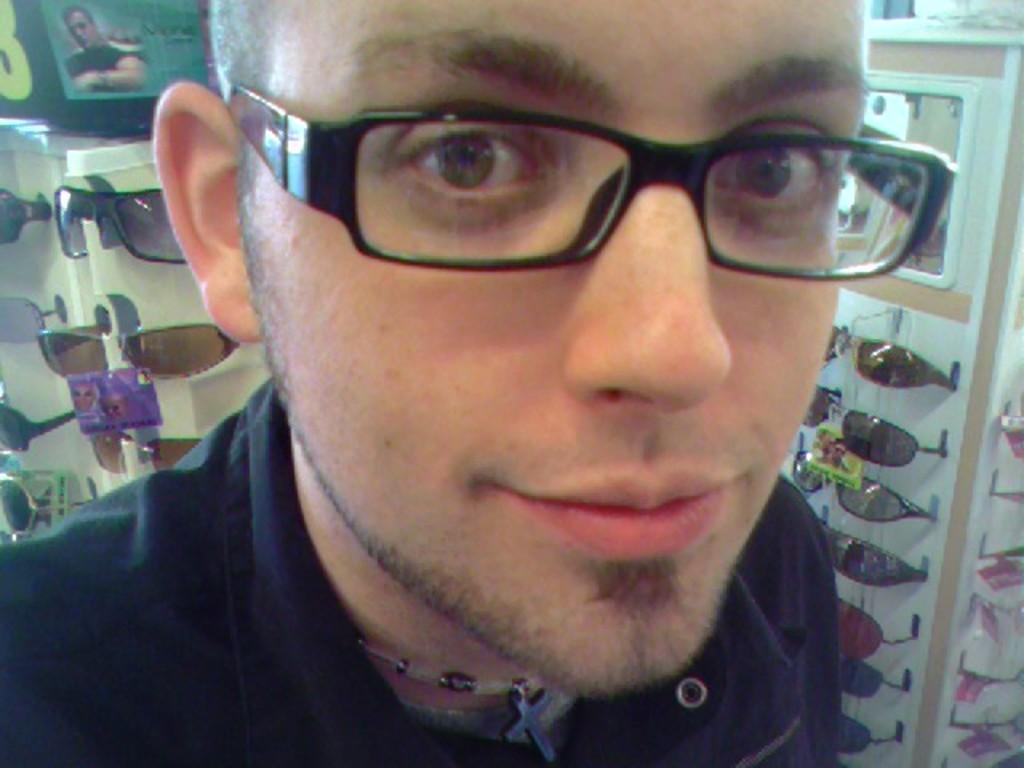In one or two sentences, can you explain what this image depicts? In this picture I can see there is a man standing and he is wearing spectacles and in the backdrop I can see there are more sun glasses. 